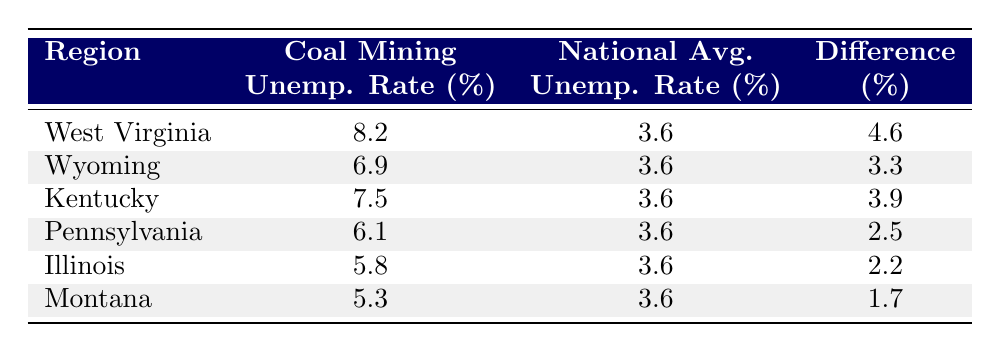What is the coal mining unemployment rate in West Virginia? The table shows that the coal mining unemployment rate in West Virginia is listed as 8.2%.
Answer: 8.2% Which region has the highest coal mining unemployment rate? By inspecting the "Coal Mining Unemployment Rate (%)" column, West Virginia has the highest rate at 8.2%.
Answer: West Virginia What is the national average unemployment rate for the regions listed? The "National Average Unemployment Rate (%)" column shows that the national average for all regions is consistently 3.6%.
Answer: 3.6% Is the coal mining unemployment rate in Pennsylvania higher than the national average? In the table, Pennsylvania has a coal mining unemployment rate of 6.1%, which is above the national average of 3.6%. Therefore, the statement is true.
Answer: Yes What is the difference in unemployment rates between Wyoming and the national average? The table indicates that Wyoming's coal mining unemployment rate is 6.9%, and the national average is 3.6%. The difference is calculated as 6.9% - 3.6% = 3.3%.
Answer: 3.3% Which region has the least difference between its coal mining unemployment rate and the national average? By examining the "Difference (%)" column, Montana has the least difference at 1.7%, which indicates more alignment with the national average compared to other regions.
Answer: Montana What is the average coal mining unemployment rate for all the regions listed? To find the average, sum all the coal mining unemployment rates (8.2 + 6.9 + 7.5 + 6.1 + 5.8 + 5.3 = 39.8%), and divide by the number of regions (6). This results in an average of 39.8% / 6 = 6.6333%, which we approximate to 6.6%.
Answer: 6.6% Are coal mining unemployment rates in all regions higher than the national average? By checking each region's coal mining unemployment rate compared to the national average, it's evident that they all exceed 3.6%. Therefore, this statement is true.
Answer: Yes What percentage difference does Illinois have compared to the national average? Illinois' coal mining unemployment rate is 5.8%, and the national average is 3.6%. The difference is calculated as 5.8% - 3.6% = 2.2%.
Answer: 2.2% 